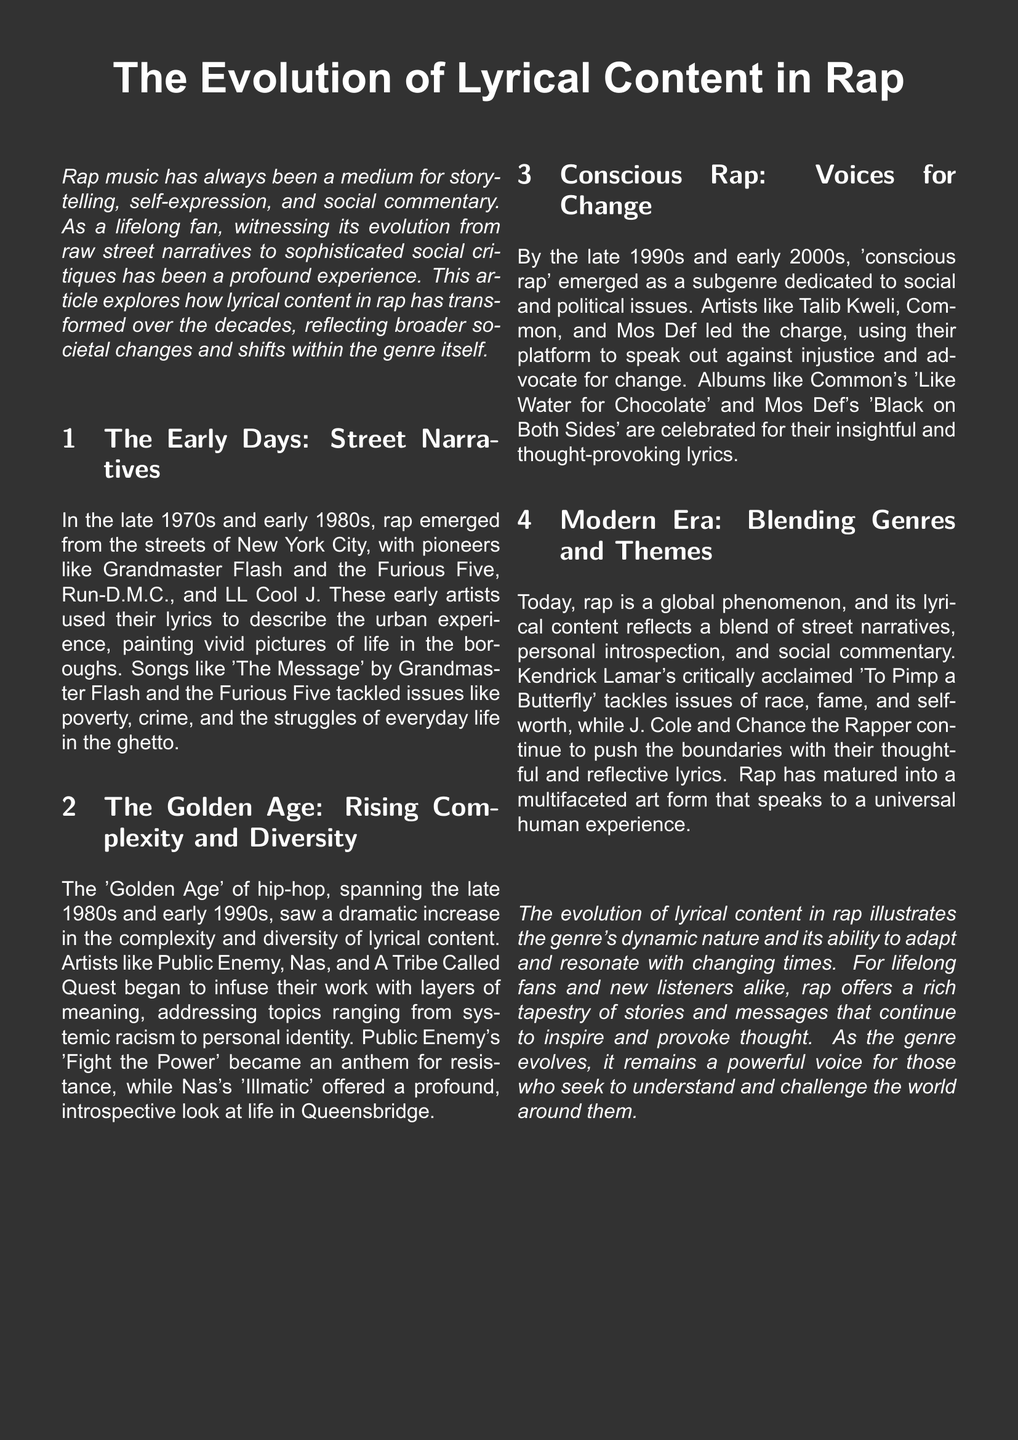What are the names of three pioneering rap artists mentioned? The document lists Grandmaster Flash and the Furious Five, Run-D.M.C., and LL Cool J as early pioneers of rap.
Answer: Grandmaster Flash and the Furious Five, Run-D.M.C., LL Cool J What song by Grandmaster Flash addressed urban issues? The document refers to "The Message" as a song that tackled issues like poverty and crime.
Answer: The Message During which era did artists like Nas and Public Enemy rise to prominence? The document states that the 'Golden Age' of hip-hop, spanning the late 1980s and early 1990s, saw these artists.
Answer: Golden Age Which subgenre dedicated itself to social and political issues? The document defines 'conscious rap' as the subgenre focusing on these topics.
Answer: Conscious rap What is the title of Kendrick Lamar's critically acclaimed album? The document mentions "To Pimp a Butterfly" as Kendrick Lamar's notable work.
Answer: To Pimp a Butterfly How does the document describe the evolution of lyrical content in rap? The text states that the evolution illustrates the genre's dynamic nature and ability to adapt.
Answer: Dynamic nature Which two modern artists are mentioned for pushing lyrical boundaries? The document specifically mentions J. Cole and Chance the Rapper as artists pushing boundaries today.
Answer: J. Cole and Chance the Rapper What does the document argue is a universal theme in modern rap music? The document states that modern rap reflects a blend of street narratives, personal introspection, and social commentary.
Answer: Universal human experience 